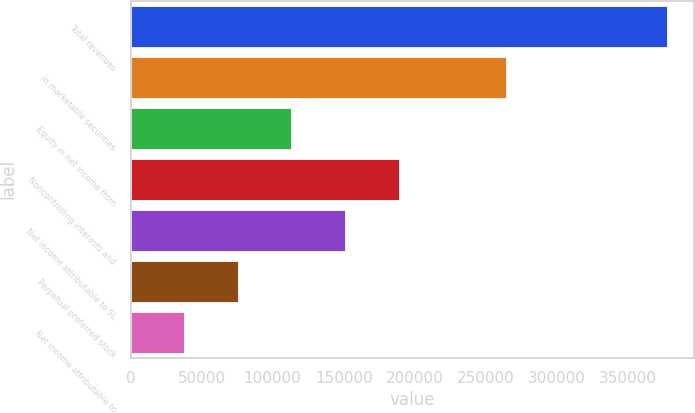Convert chart to OTSL. <chart><loc_0><loc_0><loc_500><loc_500><bar_chart><fcel>Total revenues<fcel>in marketable securities<fcel>Equity in net income from<fcel>Noncontrolling interests and<fcel>Net income attributable to SL<fcel>Perpetual preferred stock<fcel>Net income attributable to<nl><fcel>377381<fcel>264167<fcel>113214<fcel>188691<fcel>150952<fcel>75476.3<fcel>37738.2<nl></chart> 